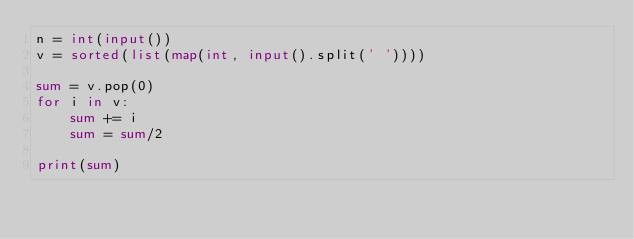Convert code to text. <code><loc_0><loc_0><loc_500><loc_500><_Python_>n = int(input())
v = sorted(list(map(int, input().split(' '))))

sum = v.pop(0)
for i in v:
    sum += i
    sum = sum/2

print(sum)</code> 